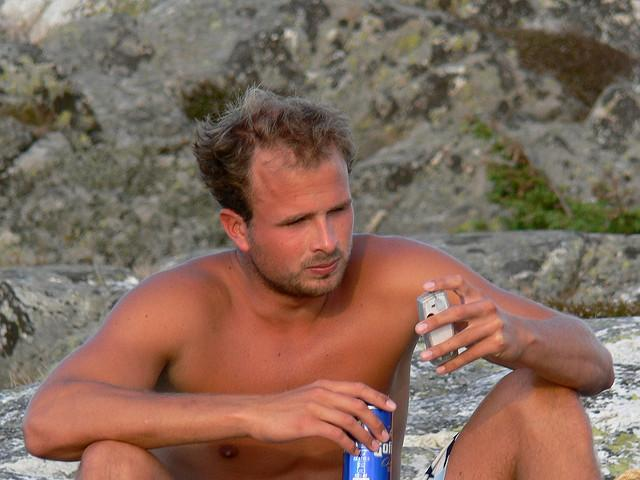What is the man holding? beer 